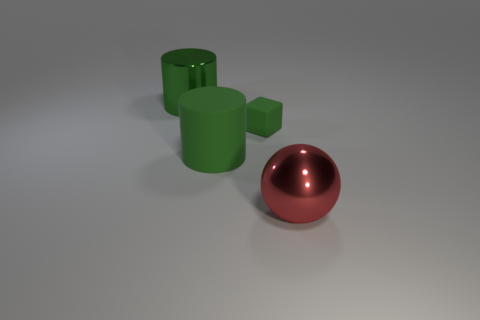Add 1 small green rubber blocks. How many objects exist? 5 Subtract all balls. How many objects are left? 3 Add 3 large objects. How many large objects are left? 6 Add 4 big red metal things. How many big red metal things exist? 5 Subtract 0 brown blocks. How many objects are left? 4 Subtract all large cyan things. Subtract all green cylinders. How many objects are left? 2 